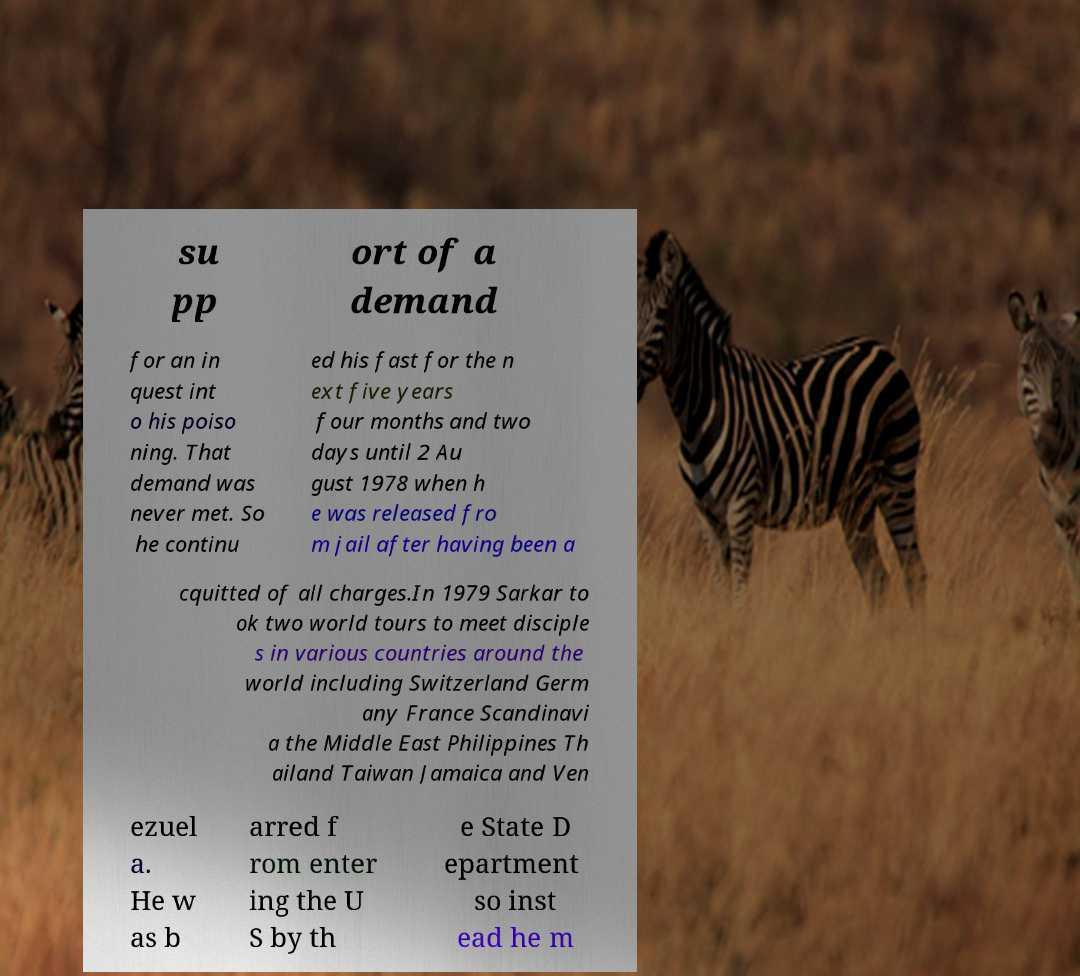Can you accurately transcribe the text from the provided image for me? su pp ort of a demand for an in quest int o his poiso ning. That demand was never met. So he continu ed his fast for the n ext five years four months and two days until 2 Au gust 1978 when h e was released fro m jail after having been a cquitted of all charges.In 1979 Sarkar to ok two world tours to meet disciple s in various countries around the world including Switzerland Germ any France Scandinavi a the Middle East Philippines Th ailand Taiwan Jamaica and Ven ezuel a. He w as b arred f rom enter ing the U S by th e State D epartment so inst ead he m 